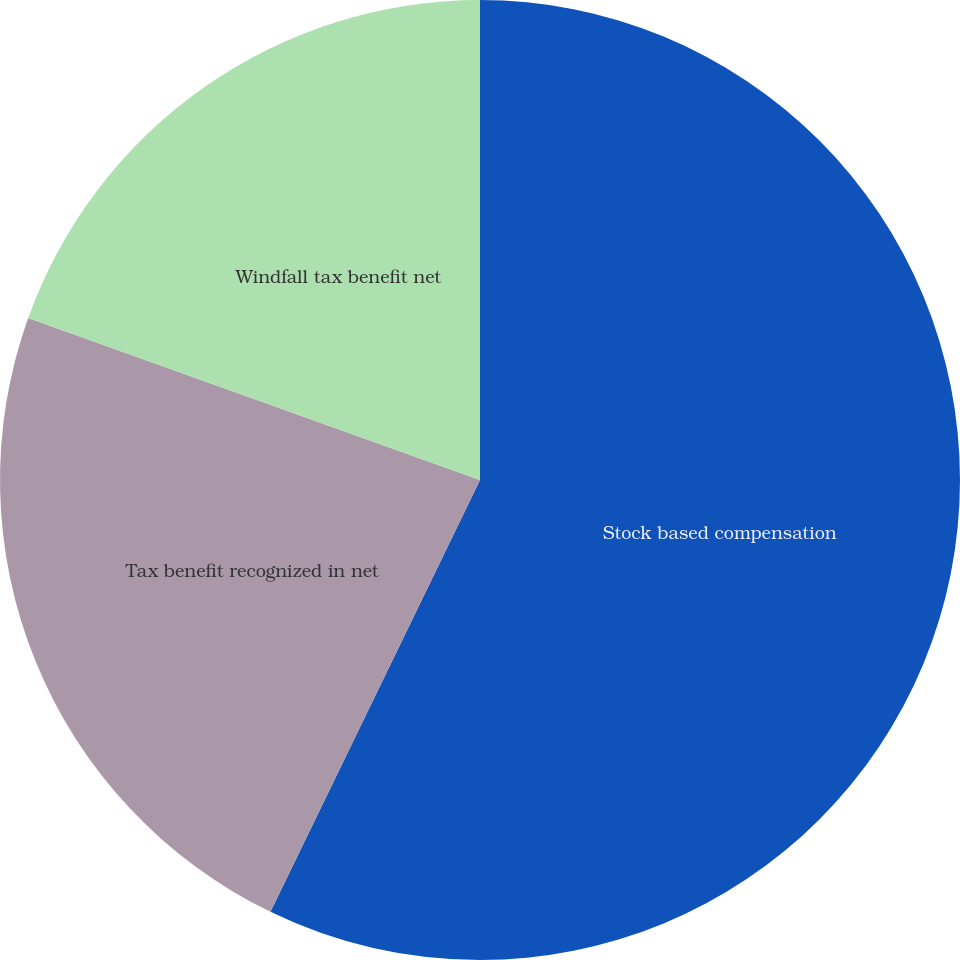<chart> <loc_0><loc_0><loc_500><loc_500><pie_chart><fcel>Stock based compensation<fcel>Tax benefit recognized in net<fcel>Windfall tax benefit net<nl><fcel>57.19%<fcel>23.29%<fcel>19.52%<nl></chart> 